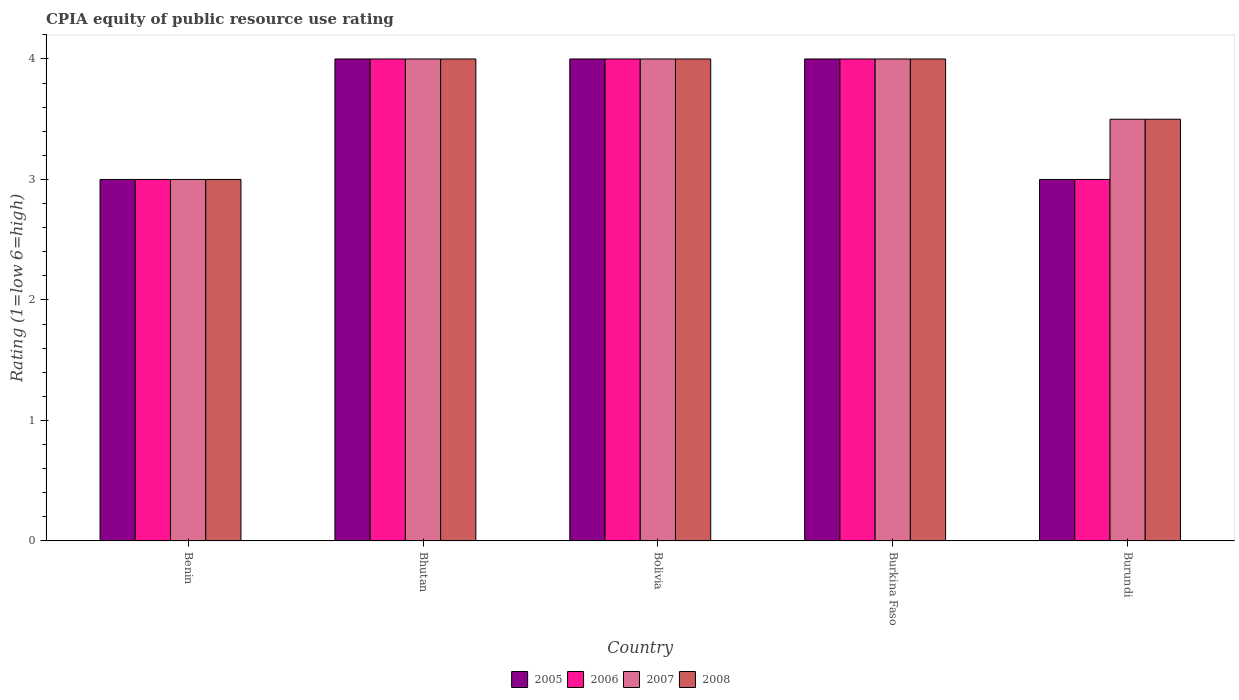Are the number of bars per tick equal to the number of legend labels?
Keep it short and to the point. Yes. What is the label of the 3rd group of bars from the left?
Ensure brevity in your answer.  Bolivia. In how many cases, is the number of bars for a given country not equal to the number of legend labels?
Give a very brief answer. 0. In which country was the CPIA rating in 2005 maximum?
Offer a terse response. Bhutan. In which country was the CPIA rating in 2006 minimum?
Provide a succinct answer. Benin. What is the total CPIA rating in 2008 in the graph?
Provide a succinct answer. 18.5. What is the difference between the CPIA rating in 2006 in Benin and that in Bolivia?
Your answer should be compact. -1. What is the difference between the CPIA rating of/in 2007 and CPIA rating of/in 2006 in Benin?
Provide a short and direct response. 0. In how many countries, is the CPIA rating in 2005 greater than 4?
Keep it short and to the point. 0. Is the difference between the CPIA rating in 2007 in Benin and Bolivia greater than the difference between the CPIA rating in 2006 in Benin and Bolivia?
Provide a short and direct response. No. What is the difference between the highest and the lowest CPIA rating in 2007?
Provide a short and direct response. 1. In how many countries, is the CPIA rating in 2006 greater than the average CPIA rating in 2006 taken over all countries?
Make the answer very short. 3. Is the sum of the CPIA rating in 2005 in Burkina Faso and Burundi greater than the maximum CPIA rating in 2006 across all countries?
Your answer should be compact. Yes. What does the 1st bar from the left in Bolivia represents?
Provide a short and direct response. 2005. What does the 1st bar from the right in Benin represents?
Provide a succinct answer. 2008. Is it the case that in every country, the sum of the CPIA rating in 2008 and CPIA rating in 2006 is greater than the CPIA rating in 2007?
Offer a terse response. Yes. Are all the bars in the graph horizontal?
Provide a succinct answer. No. How many countries are there in the graph?
Give a very brief answer. 5. What is the difference between two consecutive major ticks on the Y-axis?
Your answer should be compact. 1. Are the values on the major ticks of Y-axis written in scientific E-notation?
Provide a succinct answer. No. How many legend labels are there?
Offer a very short reply. 4. How are the legend labels stacked?
Provide a short and direct response. Horizontal. What is the title of the graph?
Your answer should be compact. CPIA equity of public resource use rating. Does "2009" appear as one of the legend labels in the graph?
Provide a succinct answer. No. What is the Rating (1=low 6=high) of 2005 in Bhutan?
Your response must be concise. 4. What is the Rating (1=low 6=high) of 2006 in Bhutan?
Provide a succinct answer. 4. What is the Rating (1=low 6=high) of 2008 in Bhutan?
Provide a succinct answer. 4. What is the Rating (1=low 6=high) in 2006 in Burkina Faso?
Your answer should be compact. 4. What is the Rating (1=low 6=high) of 2007 in Burkina Faso?
Your response must be concise. 4. What is the Rating (1=low 6=high) of 2008 in Burkina Faso?
Your response must be concise. 4. What is the Rating (1=low 6=high) of 2008 in Burundi?
Offer a terse response. 3.5. Across all countries, what is the maximum Rating (1=low 6=high) in 2005?
Keep it short and to the point. 4. Across all countries, what is the maximum Rating (1=low 6=high) in 2006?
Ensure brevity in your answer.  4. Across all countries, what is the maximum Rating (1=low 6=high) of 2007?
Your answer should be compact. 4. Across all countries, what is the minimum Rating (1=low 6=high) of 2005?
Give a very brief answer. 3. Across all countries, what is the minimum Rating (1=low 6=high) of 2006?
Offer a very short reply. 3. What is the total Rating (1=low 6=high) of 2007 in the graph?
Offer a very short reply. 18.5. What is the difference between the Rating (1=low 6=high) in 2005 in Benin and that in Bhutan?
Ensure brevity in your answer.  -1. What is the difference between the Rating (1=low 6=high) in 2006 in Benin and that in Bhutan?
Your answer should be compact. -1. What is the difference between the Rating (1=low 6=high) in 2007 in Benin and that in Bhutan?
Your answer should be compact. -1. What is the difference between the Rating (1=low 6=high) of 2008 in Benin and that in Bhutan?
Provide a succinct answer. -1. What is the difference between the Rating (1=low 6=high) of 2005 in Benin and that in Bolivia?
Make the answer very short. -1. What is the difference between the Rating (1=low 6=high) in 2007 in Benin and that in Bolivia?
Make the answer very short. -1. What is the difference between the Rating (1=low 6=high) of 2005 in Benin and that in Burkina Faso?
Your response must be concise. -1. What is the difference between the Rating (1=low 6=high) of 2006 in Benin and that in Burkina Faso?
Keep it short and to the point. -1. What is the difference between the Rating (1=low 6=high) in 2007 in Benin and that in Burkina Faso?
Keep it short and to the point. -1. What is the difference between the Rating (1=low 6=high) of 2005 in Benin and that in Burundi?
Offer a terse response. 0. What is the difference between the Rating (1=low 6=high) of 2008 in Benin and that in Burundi?
Offer a very short reply. -0.5. What is the difference between the Rating (1=low 6=high) in 2006 in Bhutan and that in Bolivia?
Ensure brevity in your answer.  0. What is the difference between the Rating (1=low 6=high) of 2007 in Bhutan and that in Bolivia?
Make the answer very short. 0. What is the difference between the Rating (1=low 6=high) in 2008 in Bhutan and that in Bolivia?
Your answer should be very brief. 0. What is the difference between the Rating (1=low 6=high) of 2006 in Bhutan and that in Burkina Faso?
Give a very brief answer. 0. What is the difference between the Rating (1=low 6=high) of 2006 in Bhutan and that in Burundi?
Provide a succinct answer. 1. What is the difference between the Rating (1=low 6=high) of 2005 in Bolivia and that in Burkina Faso?
Your answer should be compact. 0. What is the difference between the Rating (1=low 6=high) in 2006 in Bolivia and that in Burkina Faso?
Make the answer very short. 0. What is the difference between the Rating (1=low 6=high) of 2008 in Bolivia and that in Burkina Faso?
Provide a short and direct response. 0. What is the difference between the Rating (1=low 6=high) of 2005 in Bolivia and that in Burundi?
Provide a short and direct response. 1. What is the difference between the Rating (1=low 6=high) in 2006 in Bolivia and that in Burundi?
Offer a very short reply. 1. What is the difference between the Rating (1=low 6=high) of 2005 in Burkina Faso and that in Burundi?
Ensure brevity in your answer.  1. What is the difference between the Rating (1=low 6=high) in 2006 in Burkina Faso and that in Burundi?
Your answer should be very brief. 1. What is the difference between the Rating (1=low 6=high) in 2007 in Burkina Faso and that in Burundi?
Ensure brevity in your answer.  0.5. What is the difference between the Rating (1=low 6=high) in 2008 in Burkina Faso and that in Burundi?
Provide a short and direct response. 0.5. What is the difference between the Rating (1=low 6=high) in 2007 in Benin and the Rating (1=low 6=high) in 2008 in Bhutan?
Offer a very short reply. -1. What is the difference between the Rating (1=low 6=high) of 2006 in Benin and the Rating (1=low 6=high) of 2007 in Bolivia?
Make the answer very short. -1. What is the difference between the Rating (1=low 6=high) of 2007 in Benin and the Rating (1=low 6=high) of 2008 in Bolivia?
Make the answer very short. -1. What is the difference between the Rating (1=low 6=high) in 2005 in Benin and the Rating (1=low 6=high) in 2006 in Burkina Faso?
Your answer should be very brief. -1. What is the difference between the Rating (1=low 6=high) of 2005 in Benin and the Rating (1=low 6=high) of 2008 in Burundi?
Your answer should be compact. -0.5. What is the difference between the Rating (1=low 6=high) in 2006 in Benin and the Rating (1=low 6=high) in 2007 in Burundi?
Offer a terse response. -0.5. What is the difference between the Rating (1=low 6=high) in 2006 in Benin and the Rating (1=low 6=high) in 2008 in Burundi?
Give a very brief answer. -0.5. What is the difference between the Rating (1=low 6=high) in 2007 in Benin and the Rating (1=low 6=high) in 2008 in Burundi?
Your response must be concise. -0.5. What is the difference between the Rating (1=low 6=high) of 2005 in Bhutan and the Rating (1=low 6=high) of 2006 in Bolivia?
Your response must be concise. 0. What is the difference between the Rating (1=low 6=high) in 2005 in Bhutan and the Rating (1=low 6=high) in 2007 in Bolivia?
Make the answer very short. 0. What is the difference between the Rating (1=low 6=high) of 2005 in Bhutan and the Rating (1=low 6=high) of 2008 in Bolivia?
Provide a short and direct response. 0. What is the difference between the Rating (1=low 6=high) in 2006 in Bhutan and the Rating (1=low 6=high) in 2008 in Bolivia?
Keep it short and to the point. 0. What is the difference between the Rating (1=low 6=high) in 2007 in Bhutan and the Rating (1=low 6=high) in 2008 in Bolivia?
Ensure brevity in your answer.  0. What is the difference between the Rating (1=low 6=high) in 2005 in Bhutan and the Rating (1=low 6=high) in 2006 in Burkina Faso?
Offer a very short reply. 0. What is the difference between the Rating (1=low 6=high) of 2005 in Bhutan and the Rating (1=low 6=high) of 2007 in Burkina Faso?
Make the answer very short. 0. What is the difference between the Rating (1=low 6=high) of 2005 in Bhutan and the Rating (1=low 6=high) of 2008 in Burkina Faso?
Provide a succinct answer. 0. What is the difference between the Rating (1=low 6=high) in 2006 in Bhutan and the Rating (1=low 6=high) in 2008 in Burkina Faso?
Provide a short and direct response. 0. What is the difference between the Rating (1=low 6=high) in 2007 in Bhutan and the Rating (1=low 6=high) in 2008 in Burkina Faso?
Your answer should be compact. 0. What is the difference between the Rating (1=low 6=high) in 2005 in Bhutan and the Rating (1=low 6=high) in 2006 in Burundi?
Make the answer very short. 1. What is the difference between the Rating (1=low 6=high) in 2005 in Bhutan and the Rating (1=low 6=high) in 2007 in Burundi?
Provide a succinct answer. 0.5. What is the difference between the Rating (1=low 6=high) in 2006 in Bhutan and the Rating (1=low 6=high) in 2007 in Burundi?
Make the answer very short. 0.5. What is the difference between the Rating (1=low 6=high) of 2006 in Bhutan and the Rating (1=low 6=high) of 2008 in Burundi?
Provide a short and direct response. 0.5. What is the difference between the Rating (1=low 6=high) in 2007 in Bhutan and the Rating (1=low 6=high) in 2008 in Burundi?
Offer a very short reply. 0.5. What is the difference between the Rating (1=low 6=high) in 2005 in Bolivia and the Rating (1=low 6=high) in 2008 in Burkina Faso?
Give a very brief answer. 0. What is the difference between the Rating (1=low 6=high) in 2007 in Bolivia and the Rating (1=low 6=high) in 2008 in Burkina Faso?
Your answer should be very brief. 0. What is the difference between the Rating (1=low 6=high) in 2005 in Bolivia and the Rating (1=low 6=high) in 2006 in Burundi?
Your response must be concise. 1. What is the difference between the Rating (1=low 6=high) of 2005 in Bolivia and the Rating (1=low 6=high) of 2007 in Burundi?
Keep it short and to the point. 0.5. What is the difference between the Rating (1=low 6=high) of 2005 in Bolivia and the Rating (1=low 6=high) of 2008 in Burundi?
Provide a succinct answer. 0.5. What is the difference between the Rating (1=low 6=high) of 2007 in Bolivia and the Rating (1=low 6=high) of 2008 in Burundi?
Your answer should be compact. 0.5. What is the difference between the Rating (1=low 6=high) in 2005 in Burkina Faso and the Rating (1=low 6=high) in 2007 in Burundi?
Your response must be concise. 0.5. What is the average Rating (1=low 6=high) of 2007 per country?
Provide a succinct answer. 3.7. What is the average Rating (1=low 6=high) of 2008 per country?
Provide a short and direct response. 3.7. What is the difference between the Rating (1=low 6=high) of 2005 and Rating (1=low 6=high) of 2006 in Benin?
Ensure brevity in your answer.  0. What is the difference between the Rating (1=low 6=high) in 2005 and Rating (1=low 6=high) in 2007 in Benin?
Provide a short and direct response. 0. What is the difference between the Rating (1=low 6=high) of 2005 and Rating (1=low 6=high) of 2008 in Benin?
Provide a short and direct response. 0. What is the difference between the Rating (1=low 6=high) of 2007 and Rating (1=low 6=high) of 2008 in Benin?
Provide a short and direct response. 0. What is the difference between the Rating (1=low 6=high) of 2005 and Rating (1=low 6=high) of 2007 in Bhutan?
Give a very brief answer. 0. What is the difference between the Rating (1=low 6=high) of 2006 and Rating (1=low 6=high) of 2007 in Bhutan?
Offer a very short reply. 0. What is the difference between the Rating (1=low 6=high) of 2005 and Rating (1=low 6=high) of 2006 in Bolivia?
Ensure brevity in your answer.  0. What is the difference between the Rating (1=low 6=high) in 2005 and Rating (1=low 6=high) in 2007 in Bolivia?
Your answer should be compact. 0. What is the difference between the Rating (1=low 6=high) in 2005 and Rating (1=low 6=high) in 2008 in Bolivia?
Provide a short and direct response. 0. What is the difference between the Rating (1=low 6=high) in 2006 and Rating (1=low 6=high) in 2007 in Bolivia?
Keep it short and to the point. 0. What is the difference between the Rating (1=low 6=high) of 2005 and Rating (1=low 6=high) of 2007 in Burkina Faso?
Your answer should be compact. 0. What is the difference between the Rating (1=low 6=high) of 2005 and Rating (1=low 6=high) of 2008 in Burkina Faso?
Offer a very short reply. 0. What is the difference between the Rating (1=low 6=high) of 2006 and Rating (1=low 6=high) of 2007 in Burkina Faso?
Give a very brief answer. 0. What is the difference between the Rating (1=low 6=high) of 2006 and Rating (1=low 6=high) of 2008 in Burkina Faso?
Your answer should be very brief. 0. What is the difference between the Rating (1=low 6=high) in 2007 and Rating (1=low 6=high) in 2008 in Burkina Faso?
Your answer should be compact. 0. What is the difference between the Rating (1=low 6=high) of 2005 and Rating (1=low 6=high) of 2006 in Burundi?
Give a very brief answer. 0. What is the difference between the Rating (1=low 6=high) in 2005 and Rating (1=low 6=high) in 2008 in Burundi?
Your response must be concise. -0.5. What is the difference between the Rating (1=low 6=high) of 2006 and Rating (1=low 6=high) of 2008 in Burundi?
Your response must be concise. -0.5. What is the difference between the Rating (1=low 6=high) in 2007 and Rating (1=low 6=high) in 2008 in Burundi?
Offer a very short reply. 0. What is the ratio of the Rating (1=low 6=high) in 2006 in Benin to that in Bolivia?
Provide a short and direct response. 0.75. What is the ratio of the Rating (1=low 6=high) of 2005 in Benin to that in Burundi?
Keep it short and to the point. 1. What is the ratio of the Rating (1=low 6=high) in 2008 in Benin to that in Burundi?
Offer a terse response. 0.86. What is the ratio of the Rating (1=low 6=high) of 2008 in Bhutan to that in Bolivia?
Ensure brevity in your answer.  1. What is the ratio of the Rating (1=low 6=high) of 2006 in Bhutan to that in Burkina Faso?
Ensure brevity in your answer.  1. What is the ratio of the Rating (1=low 6=high) of 2006 in Bhutan to that in Burundi?
Give a very brief answer. 1.33. What is the ratio of the Rating (1=low 6=high) of 2007 in Bhutan to that in Burundi?
Make the answer very short. 1.14. What is the ratio of the Rating (1=low 6=high) of 2005 in Bolivia to that in Burkina Faso?
Your answer should be compact. 1. What is the ratio of the Rating (1=low 6=high) in 2006 in Bolivia to that in Burkina Faso?
Keep it short and to the point. 1. What is the ratio of the Rating (1=low 6=high) in 2008 in Bolivia to that in Burkina Faso?
Make the answer very short. 1. What is the ratio of the Rating (1=low 6=high) of 2007 in Bolivia to that in Burundi?
Your answer should be very brief. 1.14. What is the ratio of the Rating (1=low 6=high) in 2006 in Burkina Faso to that in Burundi?
Your answer should be compact. 1.33. What is the ratio of the Rating (1=low 6=high) in 2008 in Burkina Faso to that in Burundi?
Provide a short and direct response. 1.14. What is the difference between the highest and the second highest Rating (1=low 6=high) in 2006?
Offer a very short reply. 0. What is the difference between the highest and the second highest Rating (1=low 6=high) in 2007?
Offer a terse response. 0. What is the difference between the highest and the second highest Rating (1=low 6=high) of 2008?
Provide a short and direct response. 0. What is the difference between the highest and the lowest Rating (1=low 6=high) in 2008?
Offer a very short reply. 1. 